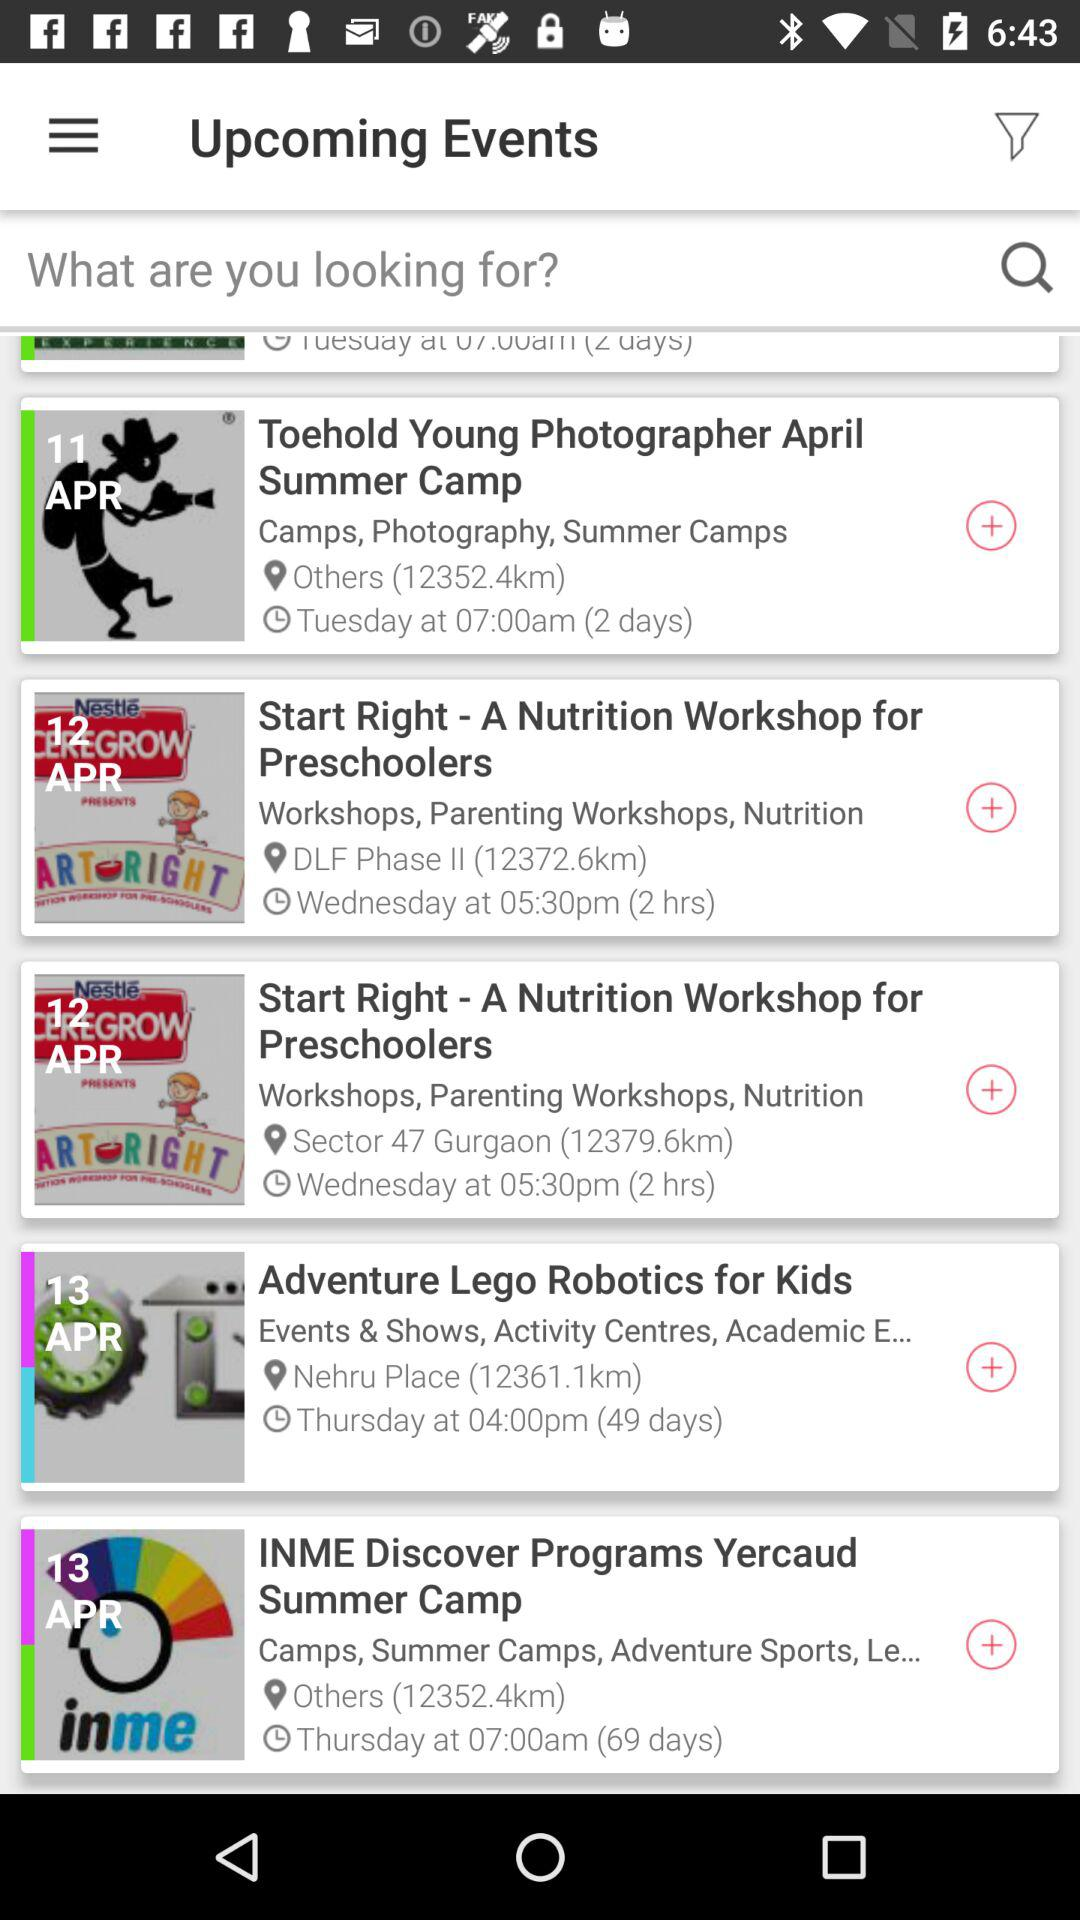How many more events have a location of Others than Sector 47 Gurgaon?
Answer the question using a single word or phrase. 1 